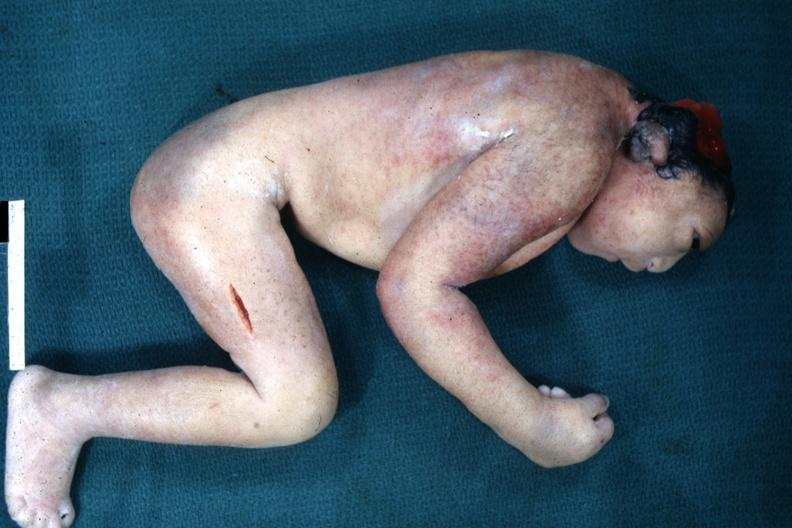does this image show lateral view of typical appearance?
Answer the question using a single word or phrase. Yes 